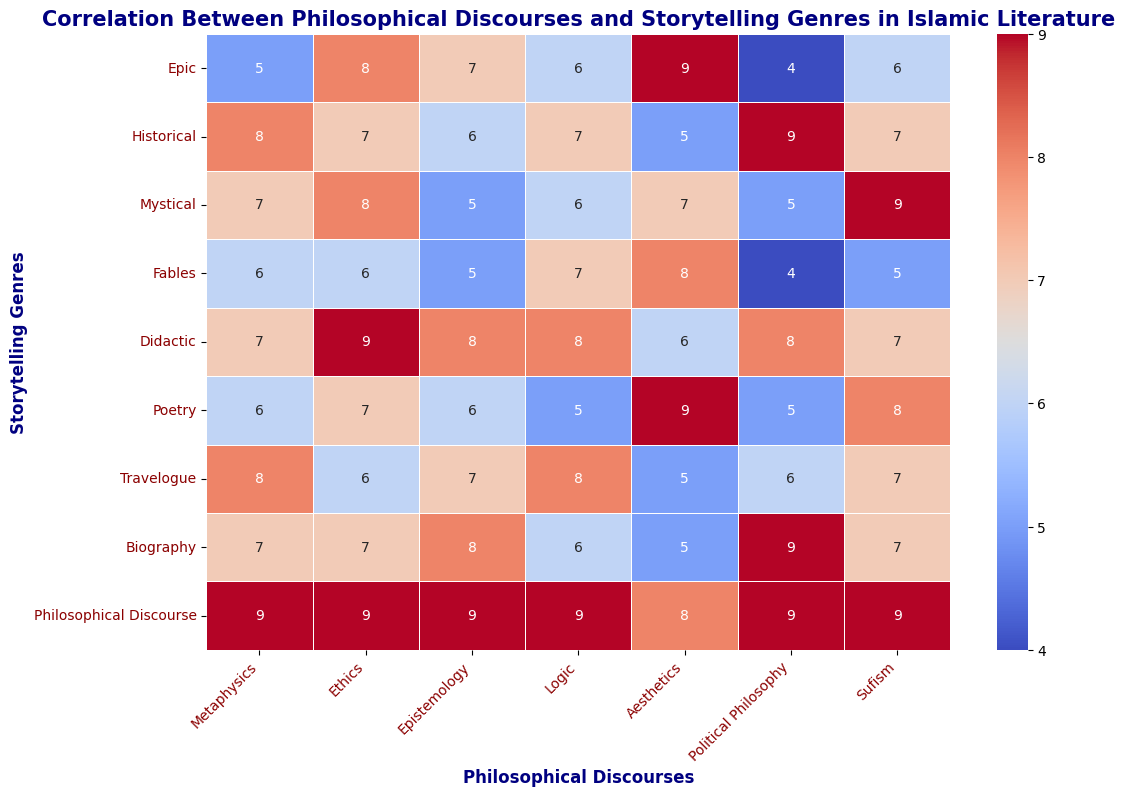Which genre emphasizes Political Philosophy the most? To determine which genre emphasizes Political Philosophy the most, look for the highest value in the Political Philosophy column. The highest value is 9, which corresponds to the genres "Historical," "Biography," and "Philosophical Discourse."
Answer: Historical, Biography, Philosophical Discourse Which genre has the highest average emphasis across all philosophical discourses? To find the genre with the highest average emphasis, compute the average value for each genre across all columns. The genre "Philosophical Discourse" has the highest average since all values are 9.
Answer: Philosophical Discourse Compare the emphasis on Aesthetics between "Epic" and "Poetry" genres and state which is higher. Locate the values under the Aesthetics column for both genres. "Epic" has a value of 9 and "Poetry" also has a value of 9, so they are equal.
Answer: Equal What is the total emphasis on Metaphysics and Logic in the "Travelogue" genre? Sum the values of Metaphysics and Logic for the "Travelogue" genre. The values are 8 (Metaphysics) and 8 (Logic). Therefore, the total is 8 + 8 = 16.
Answer: 16 Which genre places the least emphasis on Sufism? Identify the lowest value in the Sufism column. The lowest value is 5, which corresponds to the genres "Fables" and "Epic."
Answer: Fables, Epic Compute the difference in emphasis on Ethics between the "Didactic" and "Historical" genres. Find the values in the Ethics column for "Didactic" and "Historical." Subtract the value of "Historical" from "Didactic," giving 9 - 7 = 2.
Answer: 2 Which genre shows a balanced (same value) emphasis on both Metaphysics and Logic? Look for genres where the values for Metaphysics and Logic are the same. The "Didactic" genre has equal values of 7 for both Metaphysics and Logic.
Answer: Didactic Which two discourses have the highest emphasis in the "Poetry" genre? Find the values for different discourses in the "Poetry" row and identify the two highest values. Aesthetics (9) and Sufism (8) are the highest.
Answer: Aesthetics, Sufism Which genre has the closest emphasis on Metaphysics and Political Philosophy? Calculate the difference between the Metaphysics and Political Philosophy values for each genre. The "Didactic" genre has the smallest difference of 0 (7 - 7 = 0).
Answer: Didactic What is the average emphasis on Sufism across all genres? Sum the Sufism values for all genres and divide by the number of genres (9). Total: 6+7+9+5+7+8+7+7+9 = 65. Average: 65 / 9 ≈ 7.22.
Answer: 7.22 